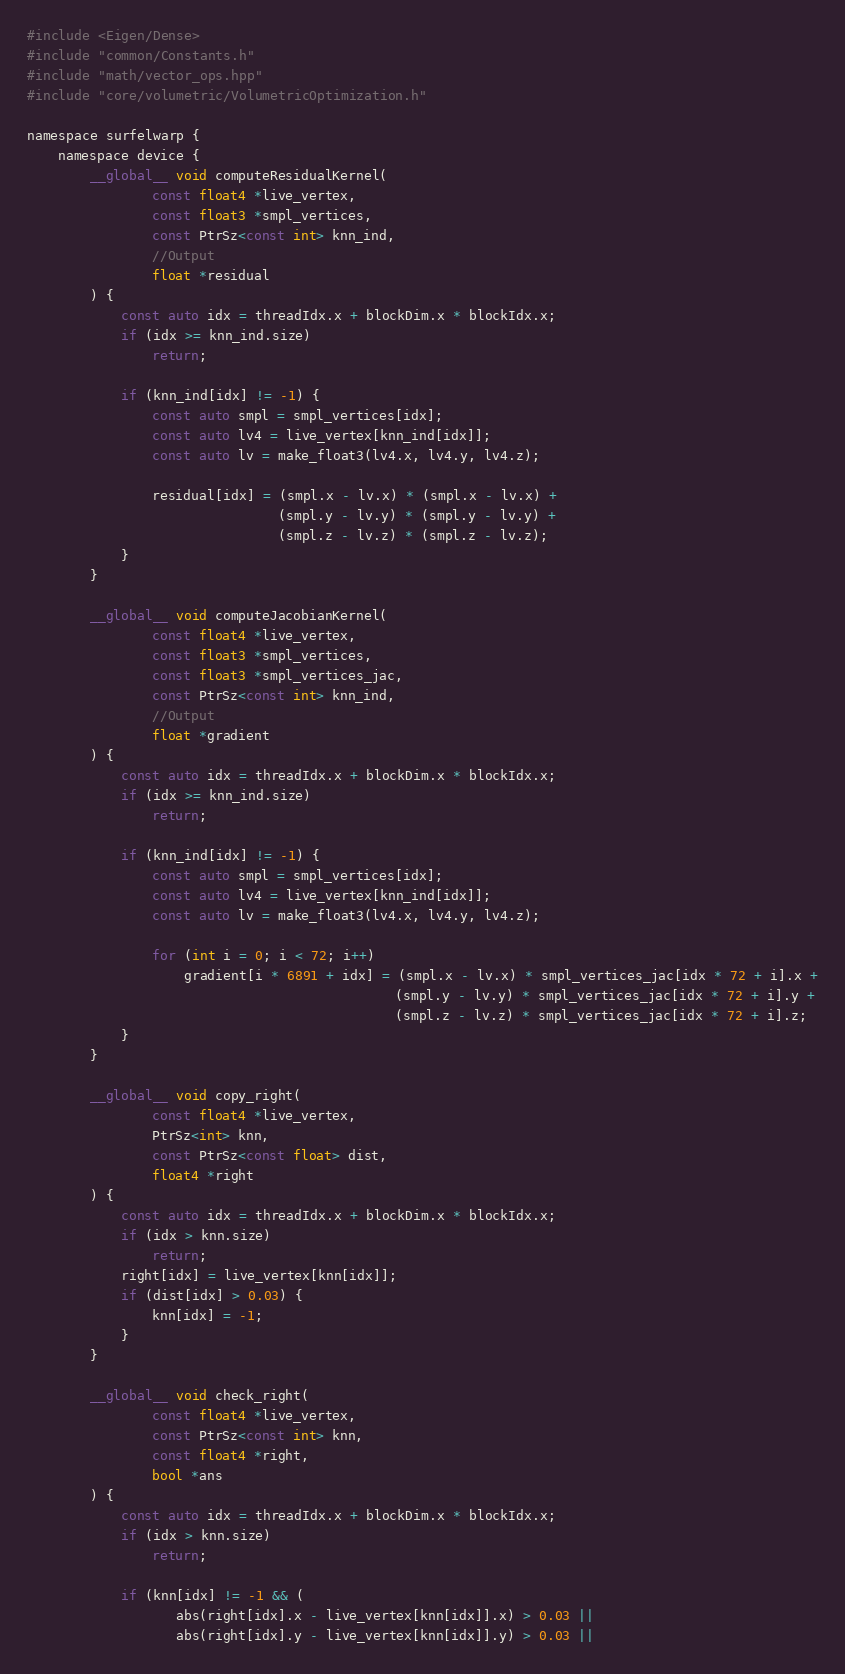Convert code to text. <code><loc_0><loc_0><loc_500><loc_500><_Cuda_>#include <Eigen/Dense>
#include "common/Constants.h"
#include "math/vector_ops.hpp"
#include "core/volumetric/VolumetricOptimization.h"

namespace surfelwarp {
    namespace device {
        __global__ void computeResidualKernel(
                const float4 *live_vertex,
                const float3 *smpl_vertices,
                const PtrSz<const int> knn_ind,
                //Output
                float *residual
        ) {
            const auto idx = threadIdx.x + blockDim.x * blockIdx.x;
            if (idx >= knn_ind.size)
                return;

            if (knn_ind[idx] != -1) {
                const auto smpl = smpl_vertices[idx];
                const auto lv4 = live_vertex[knn_ind[idx]];
                const auto lv = make_float3(lv4.x, lv4.y, lv4.z);

                residual[idx] = (smpl.x - lv.x) * (smpl.x - lv.x) +
                                (smpl.y - lv.y) * (smpl.y - lv.y) +
                                (smpl.z - lv.z) * (smpl.z - lv.z);
            }
        }

        __global__ void computeJacobianKernel(
                const float4 *live_vertex,
                const float3 *smpl_vertices,
                const float3 *smpl_vertices_jac,
                const PtrSz<const int> knn_ind,
                //Output
                float *gradient
        ) {
            const auto idx = threadIdx.x + blockDim.x * blockIdx.x;
            if (idx >= knn_ind.size)
                return;

            if (knn_ind[idx] != -1) {
                const auto smpl = smpl_vertices[idx];
                const auto lv4 = live_vertex[knn_ind[idx]];
                const auto lv = make_float3(lv4.x, lv4.y, lv4.z);

                for (int i = 0; i < 72; i++)
                    gradient[i * 6891 + idx] = (smpl.x - lv.x) * smpl_vertices_jac[idx * 72 + i].x +
                                               (smpl.y - lv.y) * smpl_vertices_jac[idx * 72 + i].y +
                                               (smpl.z - lv.z) * smpl_vertices_jac[idx * 72 + i].z;
            }
        }

        __global__ void copy_right(
                const float4 *live_vertex,
                PtrSz<int> knn,
                const PtrSz<const float> dist,
                float4 *right
        ) {
            const auto idx = threadIdx.x + blockDim.x * blockIdx.x;
            if (idx > knn.size)
                return;
            right[idx] = live_vertex[knn[idx]];
            if (dist[idx] > 0.03) {
                knn[idx] = -1;
            }
        }

        __global__ void check_right(
                const float4 *live_vertex,
                const PtrSz<const int> knn,
                const float4 *right,
                bool *ans
        ) {
            const auto idx = threadIdx.x + blockDim.x * blockIdx.x;
            if (idx > knn.size)
                return;

            if (knn[idx] != -1 && (
                   abs(right[idx].x - live_vertex[knn[idx]].x) > 0.03 ||
                   abs(right[idx].y - live_vertex[knn[idx]].y) > 0.03 ||</code> 